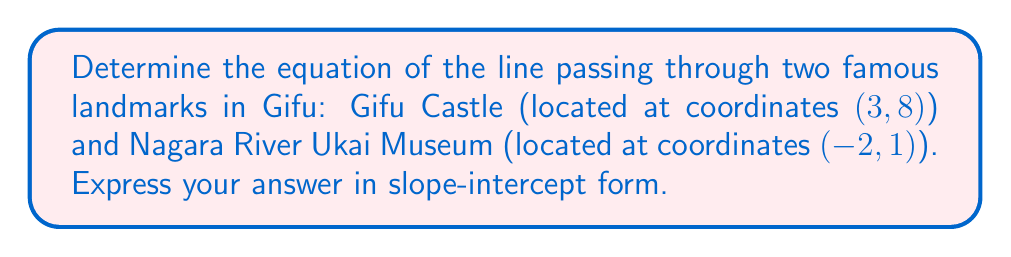Teach me how to tackle this problem. To find the equation of the line passing through two points, we'll use the point-slope form and then convert it to slope-intercept form. Let's follow these steps:

1. Identify the two points:
   Point 1 (Gifu Castle): $(x_1, y_1) = (3, 8)$
   Point 2 (Nagara River Ukai Museum): $(x_2, y_2) = (-2, 1)$

2. Calculate the slope (m) using the slope formula:
   $m = \frac{y_2 - y_1}{x_2 - x_1} = \frac{1 - 8}{-2 - 3} = \frac{-7}{-5} = \frac{7}{5}$

3. Use the point-slope form of a line with either point. Let's use (3, 8):
   $y - y_1 = m(x - x_1)$
   $y - 8 = \frac{7}{5}(x - 3)$

4. Expand the equation:
   $y - 8 = \frac{7x}{5} - \frac{21}{5}$

5. Solve for y to get the slope-intercept form $(y = mx + b)$:
   $y = \frac{7x}{5} - \frac{21}{5} + 8$
   $y = \frac{7x}{5} + \frac{19}{5}$

Therefore, the equation of the line passing through Gifu Castle and Nagara River Ukai Museum in slope-intercept form is $y = \frac{7x}{5} + \frac{19}{5}$.
Answer: $y = \frac{7x}{5} + \frac{19}{5}$ 